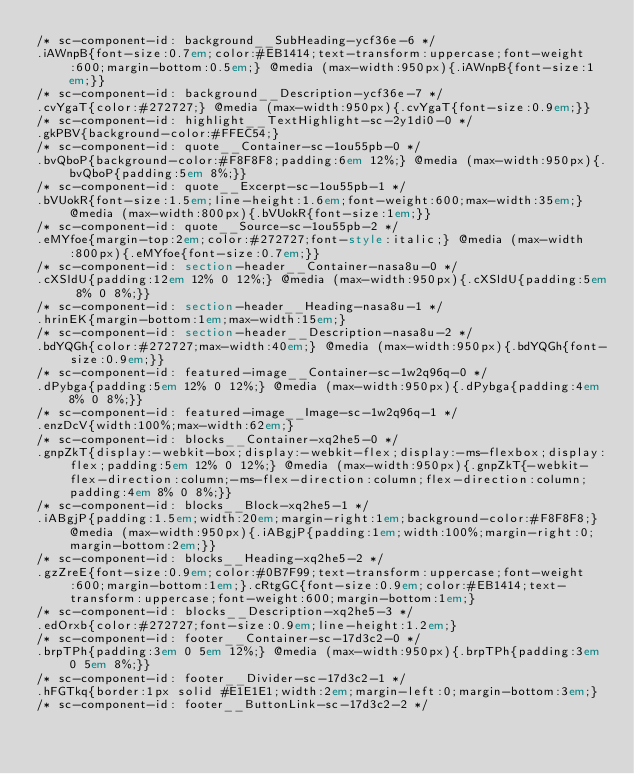<code> <loc_0><loc_0><loc_500><loc_500><_HTML_>/* sc-component-id: background__SubHeading-ycf36e-6 */
.iAWnpB{font-size:0.7em;color:#EB1414;text-transform:uppercase;font-weight:600;margin-bottom:0.5em;} @media (max-width:950px){.iAWnpB{font-size:1em;}}
/* sc-component-id: background__Description-ycf36e-7 */
.cvYgaT{color:#272727;} @media (max-width:950px){.cvYgaT{font-size:0.9em;}}
/* sc-component-id: highlight__TextHighlight-sc-2y1di0-0 */
.gkPBV{background-color:#FFEC54;}
/* sc-component-id: quote__Container-sc-1ou55pb-0 */
.bvQboP{background-color:#F8F8F8;padding:6em 12%;} @media (max-width:950px){.bvQboP{padding:5em 8%;}}
/* sc-component-id: quote__Excerpt-sc-1ou55pb-1 */
.bVUokR{font-size:1.5em;line-height:1.6em;font-weight:600;max-width:35em;} @media (max-width:800px){.bVUokR{font-size:1em;}}
/* sc-component-id: quote__Source-sc-1ou55pb-2 */
.eMYfoe{margin-top:2em;color:#272727;font-style:italic;} @media (max-width:800px){.eMYfoe{font-size:0.7em;}}
/* sc-component-id: section-header__Container-nasa8u-0 */
.cXSldU{padding:12em 12% 0 12%;} @media (max-width:950px){.cXSldU{padding:5em 8% 0 8%;}}
/* sc-component-id: section-header__Heading-nasa8u-1 */
.hrinEK{margin-bottom:1em;max-width:15em;}
/* sc-component-id: section-header__Description-nasa8u-2 */
.bdYQGh{color:#272727;max-width:40em;} @media (max-width:950px){.bdYQGh{font-size:0.9em;}}
/* sc-component-id: featured-image__Container-sc-1w2q96q-0 */
.dPybga{padding:5em 12% 0 12%;} @media (max-width:950px){.dPybga{padding:4em 8% 0 8%;}}
/* sc-component-id: featured-image__Image-sc-1w2q96q-1 */
.enzDcV{width:100%;max-width:62em;}
/* sc-component-id: blocks__Container-xq2he5-0 */
.gnpZkT{display:-webkit-box;display:-webkit-flex;display:-ms-flexbox;display:flex;padding:5em 12% 0 12%;} @media (max-width:950px){.gnpZkT{-webkit-flex-direction:column;-ms-flex-direction:column;flex-direction:column;padding:4em 8% 0 8%;}}
/* sc-component-id: blocks__Block-xq2he5-1 */
.iABgjP{padding:1.5em;width:20em;margin-right:1em;background-color:#F8F8F8;} @media (max-width:950px){.iABgjP{padding:1em;width:100%;margin-right:0;margin-bottom:2em;}}
/* sc-component-id: blocks__Heading-xq2he5-2 */
.gzZreE{font-size:0.9em;color:#0B7F99;text-transform:uppercase;font-weight:600;margin-bottom:1em;}.cRtgGC{font-size:0.9em;color:#EB1414;text-transform:uppercase;font-weight:600;margin-bottom:1em;}
/* sc-component-id: blocks__Description-xq2he5-3 */
.edOrxb{color:#272727;font-size:0.9em;line-height:1.2em;}
/* sc-component-id: footer__Container-sc-17d3c2-0 */
.brpTPh{padding:3em 0 5em 12%;} @media (max-width:950px){.brpTPh{padding:3em 0 5em 8%;}}
/* sc-component-id: footer__Divider-sc-17d3c2-1 */
.hFGTkq{border:1px solid #E1E1E1;width:2em;margin-left:0;margin-bottom:3em;}
/* sc-component-id: footer__ButtonLink-sc-17d3c2-2 */</code> 